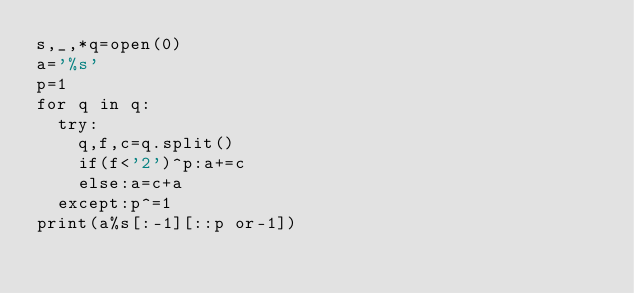Convert code to text. <code><loc_0><loc_0><loc_500><loc_500><_Python_>s,_,*q=open(0)
a='%s'
p=1
for q in q:
  try:
    q,f,c=q.split()
    if(f<'2')^p:a+=c
    else:a=c+a
  except:p^=1
print(a%s[:-1][::p or-1])</code> 